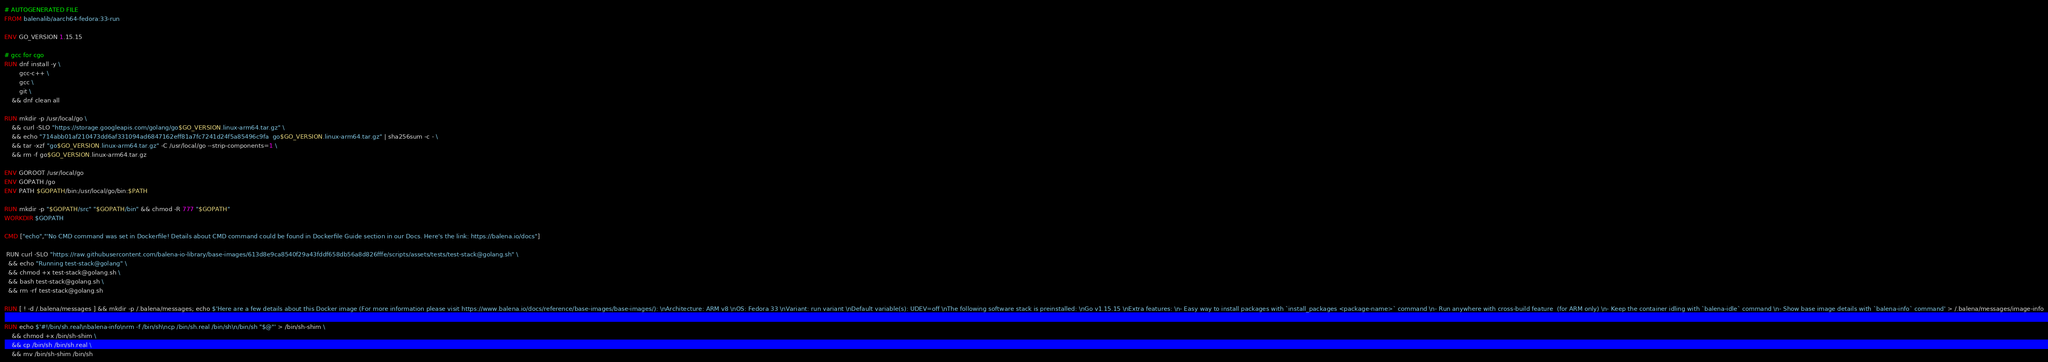Convert code to text. <code><loc_0><loc_0><loc_500><loc_500><_Dockerfile_># AUTOGENERATED FILE
FROM balenalib/aarch64-fedora:33-run

ENV GO_VERSION 1.15.15

# gcc for cgo
RUN dnf install -y \
		gcc-c++ \
		gcc \
		git \
	&& dnf clean all

RUN mkdir -p /usr/local/go \
	&& curl -SLO "https://storage.googleapis.com/golang/go$GO_VERSION.linux-arm64.tar.gz" \
	&& echo "714abb01af210473dd6af331094ad6847162eff81a7fc7241d24f5a85496c9fa  go$GO_VERSION.linux-arm64.tar.gz" | sha256sum -c - \
	&& tar -xzf "go$GO_VERSION.linux-arm64.tar.gz" -C /usr/local/go --strip-components=1 \
	&& rm -f go$GO_VERSION.linux-arm64.tar.gz

ENV GOROOT /usr/local/go
ENV GOPATH /go
ENV PATH $GOPATH/bin:/usr/local/go/bin:$PATH

RUN mkdir -p "$GOPATH/src" "$GOPATH/bin" && chmod -R 777 "$GOPATH"
WORKDIR $GOPATH

CMD ["echo","'No CMD command was set in Dockerfile! Details about CMD command could be found in Dockerfile Guide section in our Docs. Here's the link: https://balena.io/docs"]

 RUN curl -SLO "https://raw.githubusercontent.com/balena-io-library/base-images/613d8e9ca8540f29a43fddf658db56a8d826fffe/scripts/assets/tests/test-stack@golang.sh" \
  && echo "Running test-stack@golang" \
  && chmod +x test-stack@golang.sh \
  && bash test-stack@golang.sh \
  && rm -rf test-stack@golang.sh 

RUN [ ! -d /.balena/messages ] && mkdir -p /.balena/messages; echo $'Here are a few details about this Docker image (For more information please visit https://www.balena.io/docs/reference/base-images/base-images/): \nArchitecture: ARM v8 \nOS: Fedora 33 \nVariant: run variant \nDefault variable(s): UDEV=off \nThe following software stack is preinstalled: \nGo v1.15.15 \nExtra features: \n- Easy way to install packages with `install_packages <package-name>` command \n- Run anywhere with cross-build feature  (for ARM only) \n- Keep the container idling with `balena-idle` command \n- Show base image details with `balena-info` command' > /.balena/messages/image-info

RUN echo $'#!/bin/sh.real\nbalena-info\nrm -f /bin/sh\ncp /bin/sh.real /bin/sh\n/bin/sh "$@"' > /bin/sh-shim \
	&& chmod +x /bin/sh-shim \
	&& cp /bin/sh /bin/sh.real \
	&& mv /bin/sh-shim /bin/sh</code> 